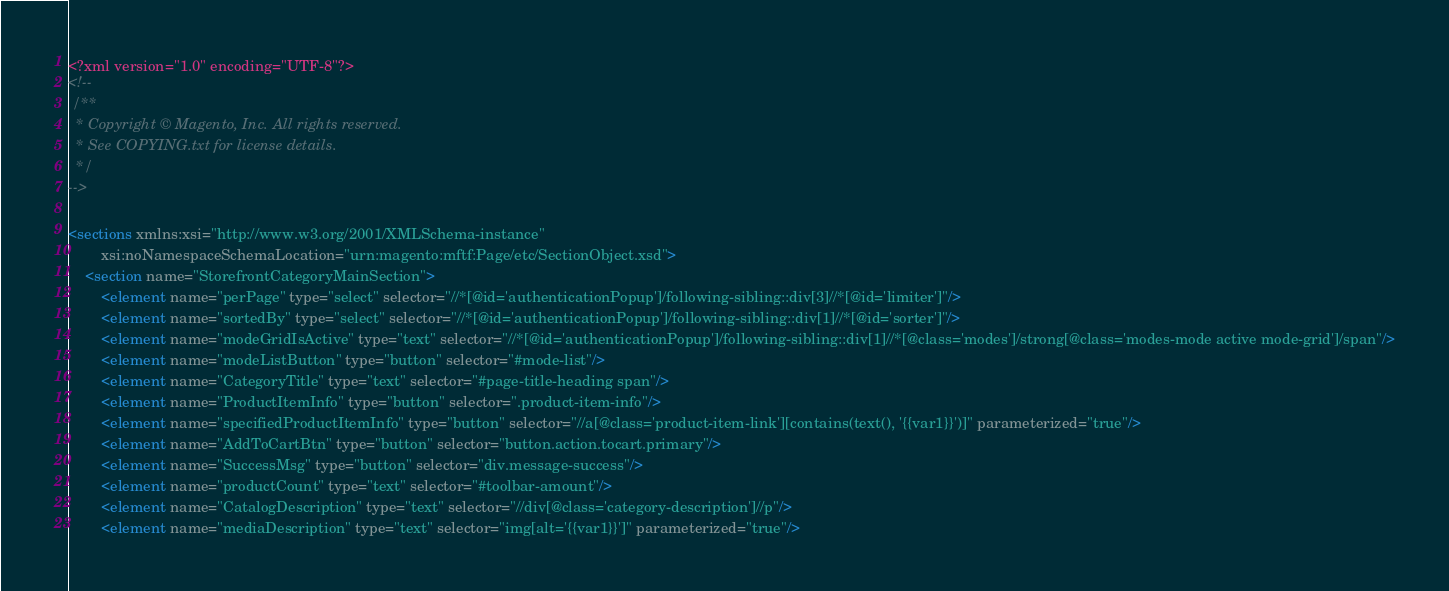<code> <loc_0><loc_0><loc_500><loc_500><_XML_><?xml version="1.0" encoding="UTF-8"?>
<!--
 /**
  * Copyright © Magento, Inc. All rights reserved.
  * See COPYING.txt for license details.
  */
-->

<sections xmlns:xsi="http://www.w3.org/2001/XMLSchema-instance"
        xsi:noNamespaceSchemaLocation="urn:magento:mftf:Page/etc/SectionObject.xsd">
    <section name="StorefrontCategoryMainSection">
        <element name="perPage" type="select" selector="//*[@id='authenticationPopup']/following-sibling::div[3]//*[@id='limiter']"/>
        <element name="sortedBy" type="select" selector="//*[@id='authenticationPopup']/following-sibling::div[1]//*[@id='sorter']"/>
        <element name="modeGridIsActive" type="text" selector="//*[@id='authenticationPopup']/following-sibling::div[1]//*[@class='modes']/strong[@class='modes-mode active mode-grid']/span"/>
        <element name="modeListButton" type="button" selector="#mode-list"/>
        <element name="CategoryTitle" type="text" selector="#page-title-heading span"/>
        <element name="ProductItemInfo" type="button" selector=".product-item-info"/>
        <element name="specifiedProductItemInfo" type="button" selector="//a[@class='product-item-link'][contains(text(), '{{var1}}')]" parameterized="true"/>
        <element name="AddToCartBtn" type="button" selector="button.action.tocart.primary"/>
        <element name="SuccessMsg" type="button" selector="div.message-success"/>
        <element name="productCount" type="text" selector="#toolbar-amount"/>
        <element name="CatalogDescription" type="text" selector="//div[@class='category-description']//p"/>
        <element name="mediaDescription" type="text" selector="img[alt='{{var1}}']" parameterized="true"/></code> 